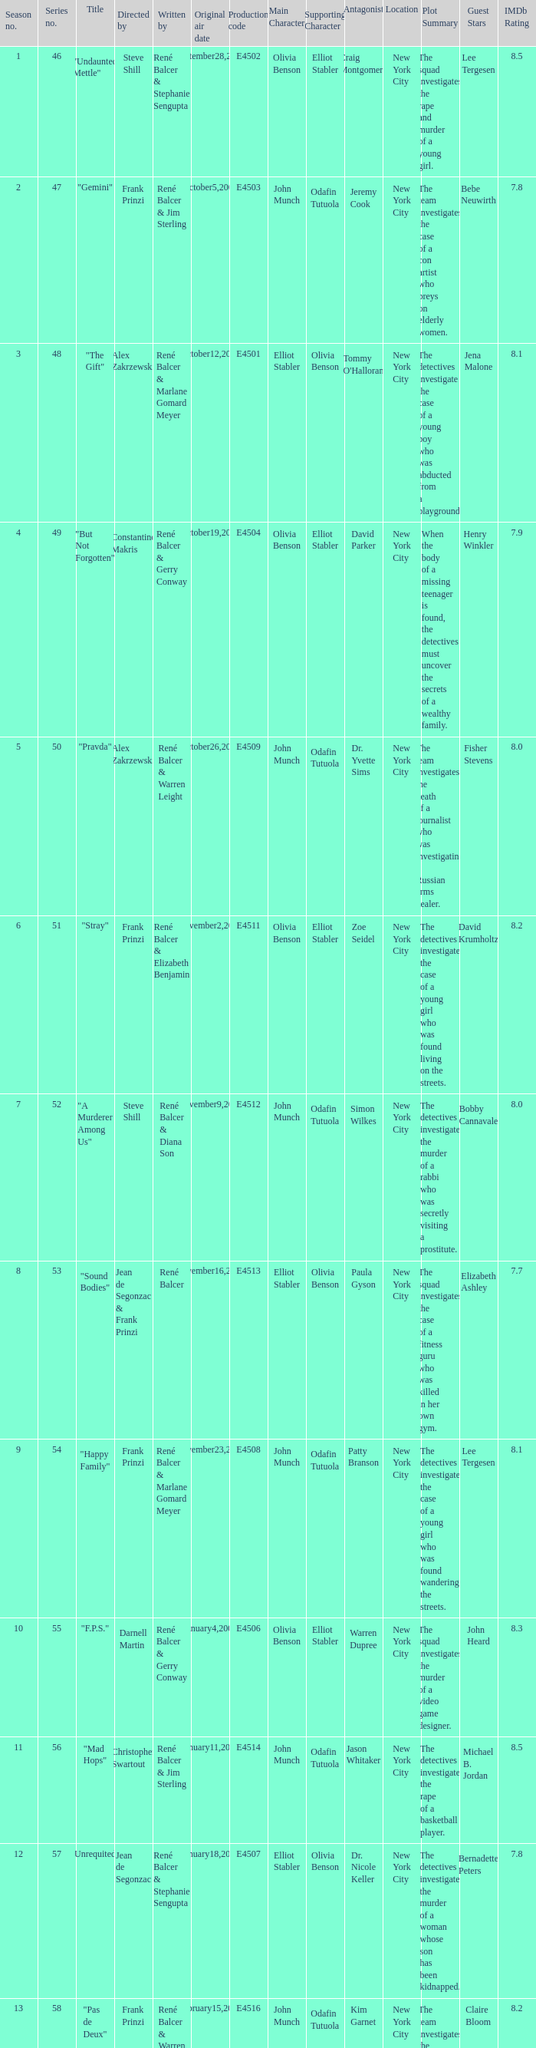What episode number in the season is titled "stray"? 6.0. 